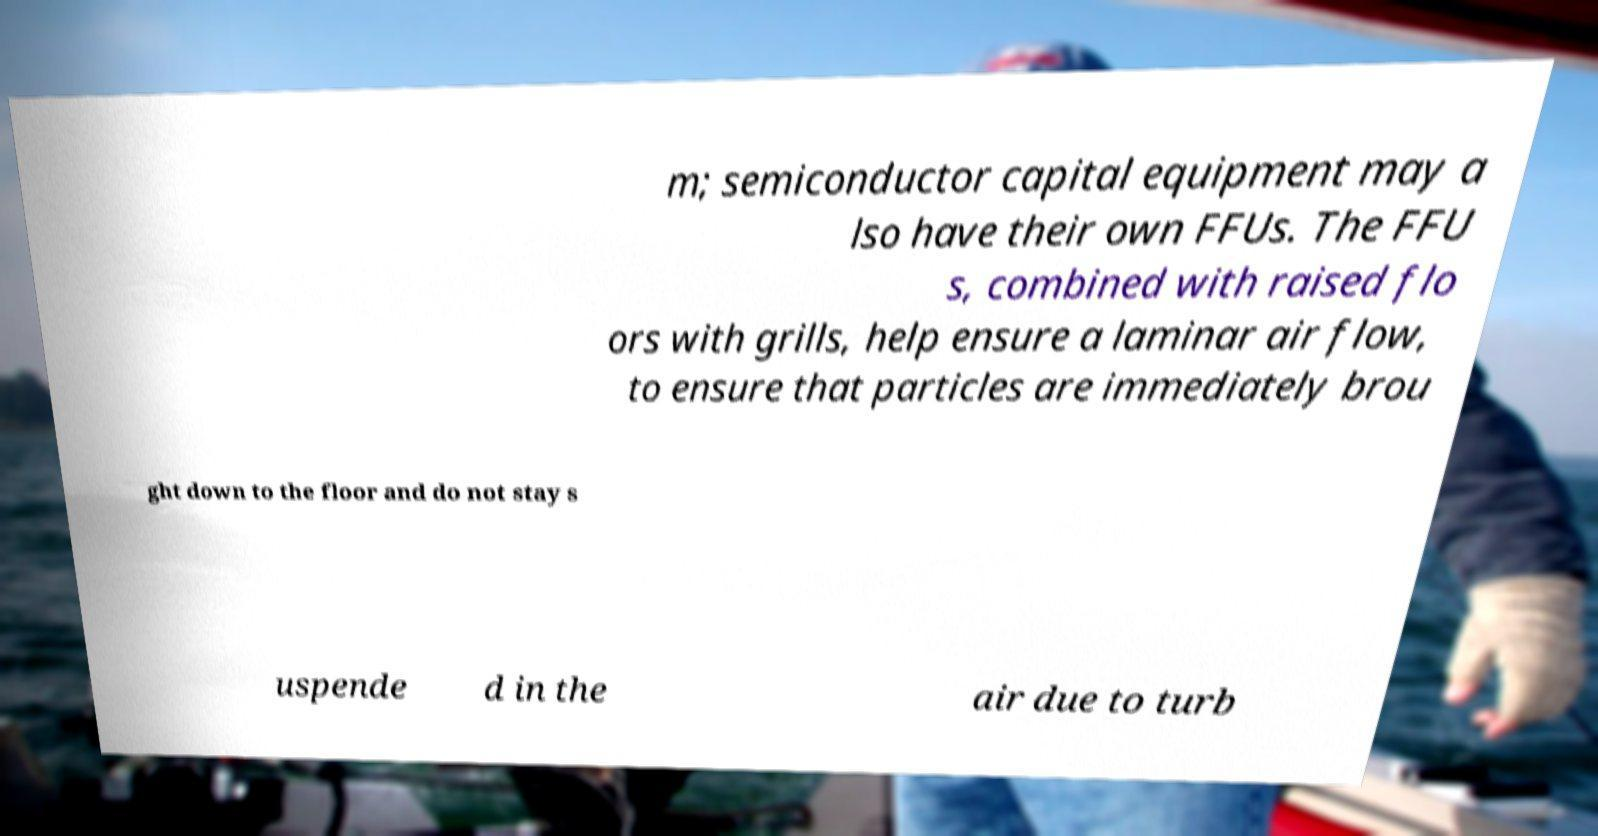Please read and relay the text visible in this image. What does it say? m; semiconductor capital equipment may a lso have their own FFUs. The FFU s, combined with raised flo ors with grills, help ensure a laminar air flow, to ensure that particles are immediately brou ght down to the floor and do not stay s uspende d in the air due to turb 